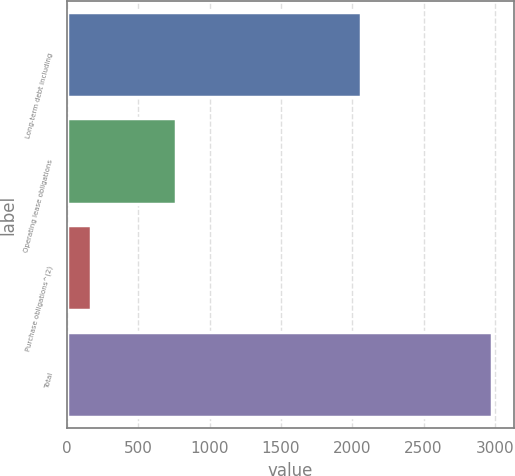<chart> <loc_0><loc_0><loc_500><loc_500><bar_chart><fcel>Long-term debt including<fcel>Operating lease obligations<fcel>Purchase obligations^(2)<fcel>Total<nl><fcel>2059<fcel>761<fcel>164<fcel>2984<nl></chart> 